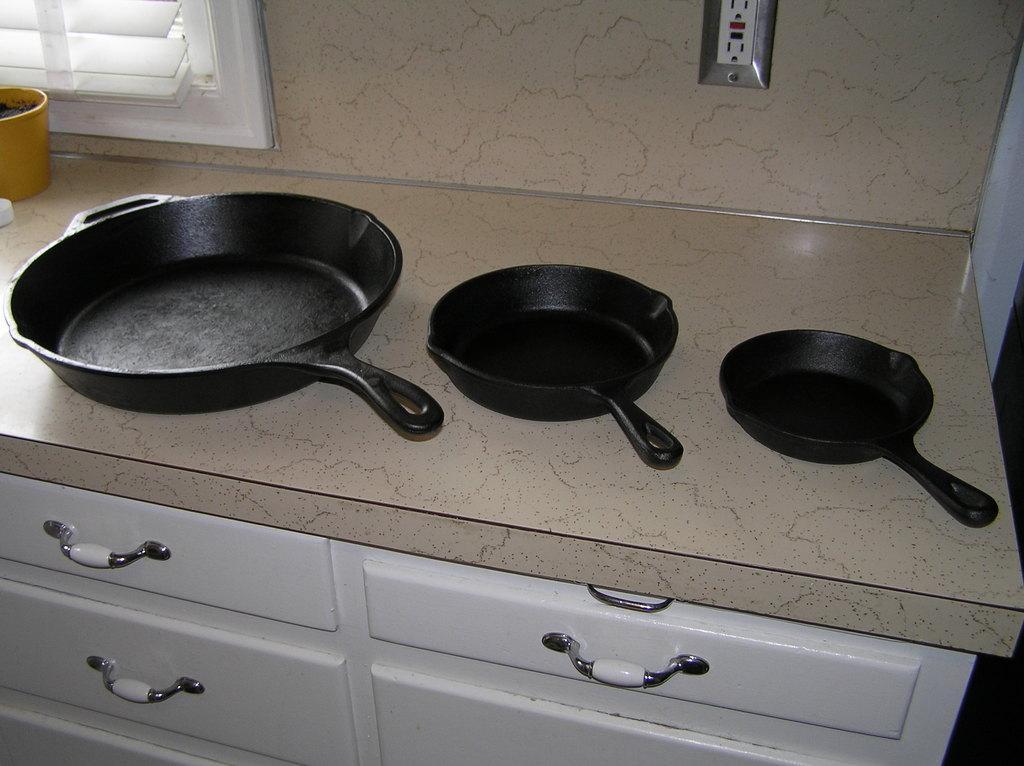Can you describe this image briefly? These are the different sizes of frying pans, which are placed on the table. I can see the drawers with the handles. On the left side of the image, that looks like a small cup, which is yellow in color. I think this is a window. At the top of the image, I can see a socket, which is attached to a wall. 